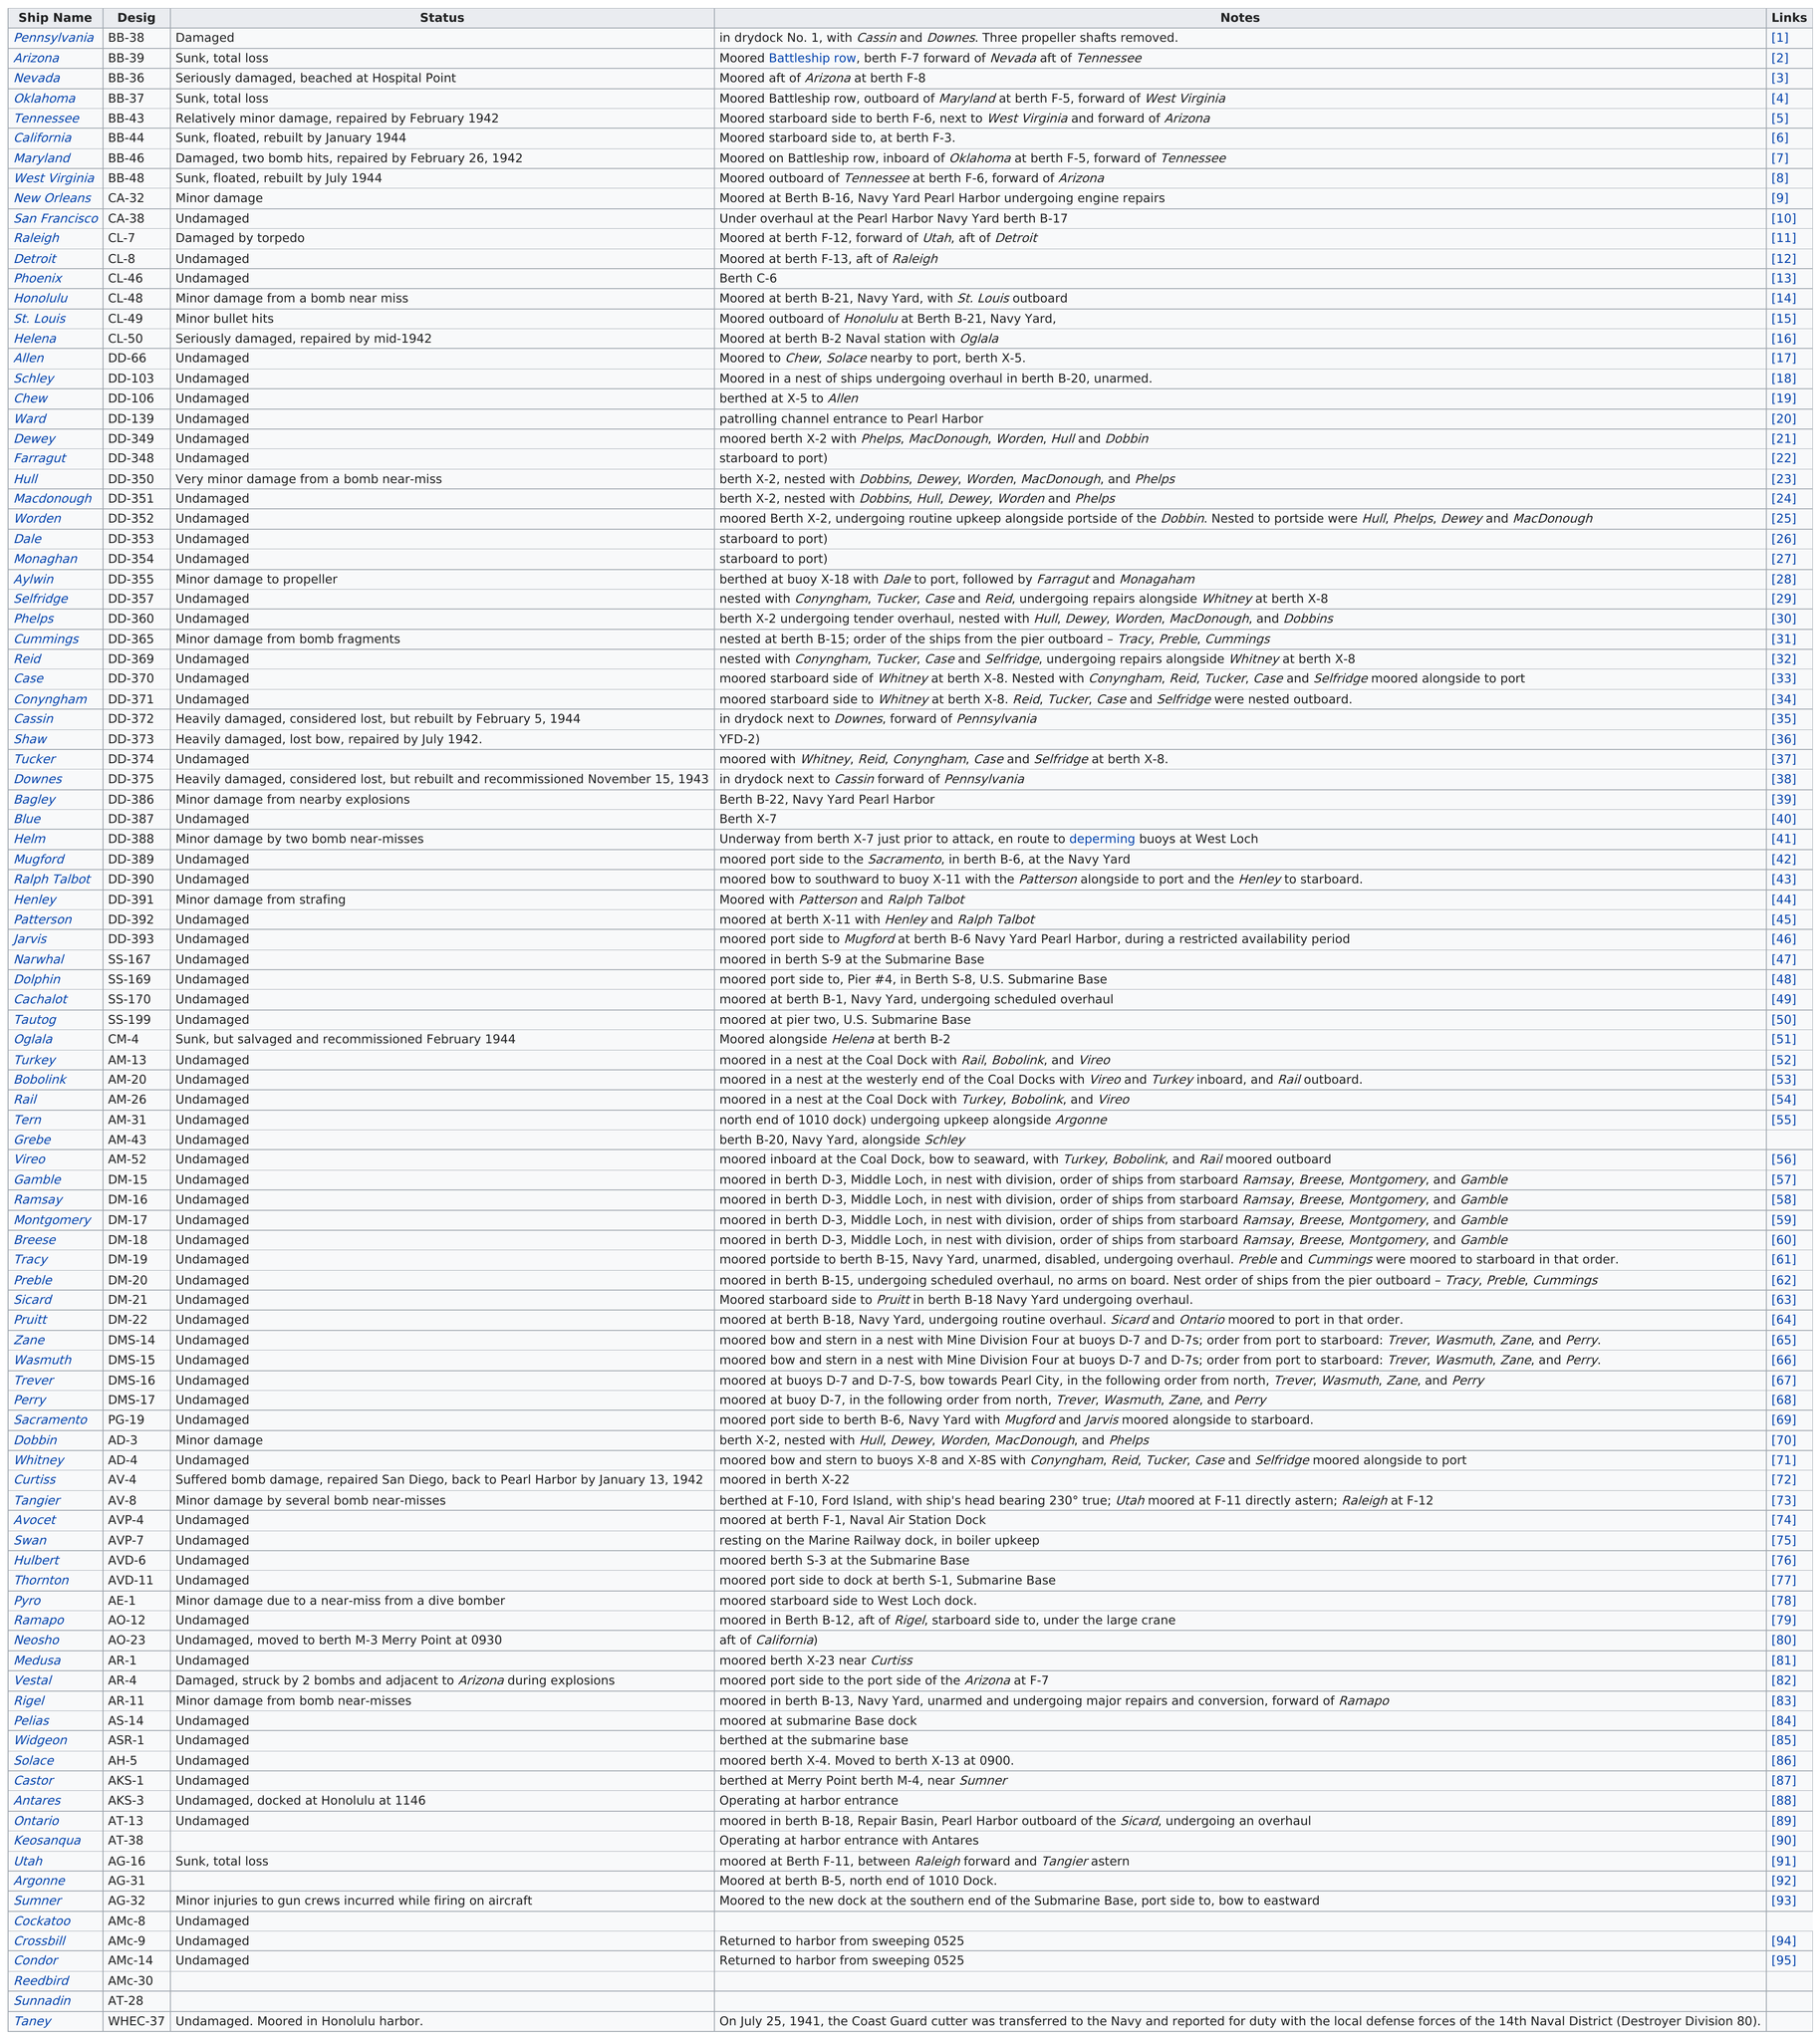Draw attention to some important aspects in this diagram. Nine ships are named after states. The ship listed after the Arizona is the Nevada. The status of the last ship was undamaged and it was moored in Honolulu harbor. The first ship listed as undamaged is San Francisco. The Maryland is preceded by a ship named the California. 